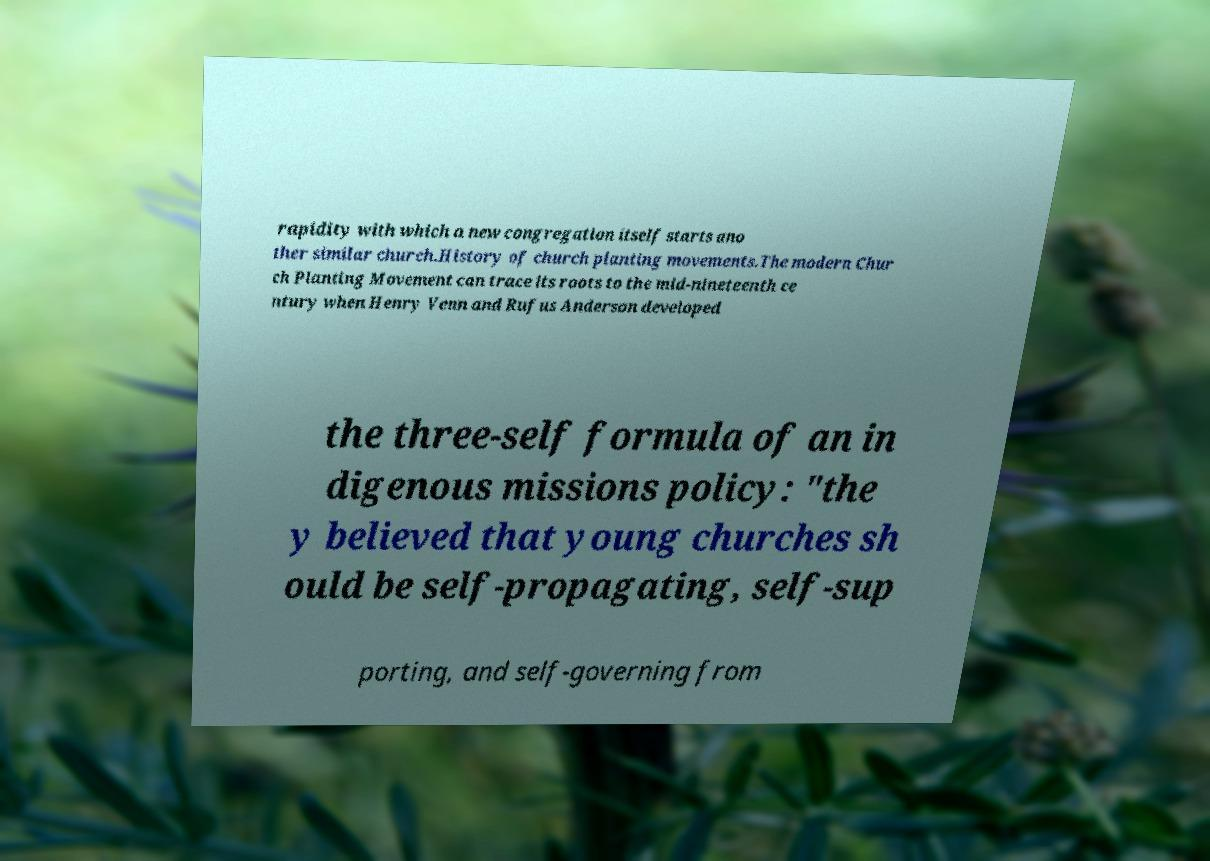For documentation purposes, I need the text within this image transcribed. Could you provide that? rapidity with which a new congregation itself starts ano ther similar church.History of church planting movements.The modern Chur ch Planting Movement can trace its roots to the mid-nineteenth ce ntury when Henry Venn and Rufus Anderson developed the three-self formula of an in digenous missions policy: "the y believed that young churches sh ould be self-propagating, self-sup porting, and self-governing from 